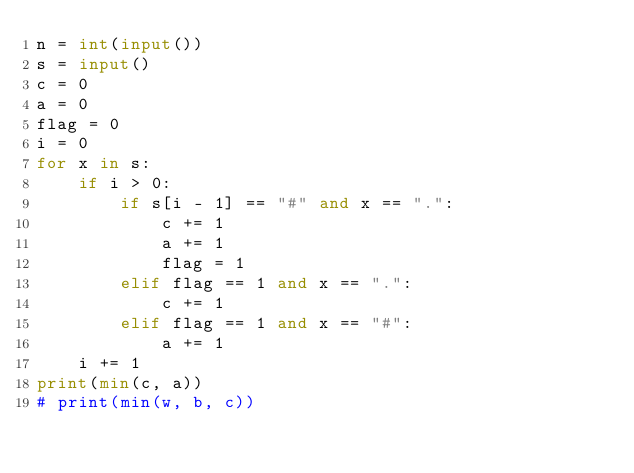<code> <loc_0><loc_0><loc_500><loc_500><_Python_>n = int(input())
s = input()
c = 0
a = 0
flag = 0
i = 0
for x in s:
    if i > 0:
        if s[i - 1] == "#" and x == ".":
            c += 1
            a += 1
            flag = 1
        elif flag == 1 and x == ".":
            c += 1
        elif flag == 1 and x == "#":
            a += 1
    i += 1
print(min(c, a))
# print(min(w, b, c))</code> 